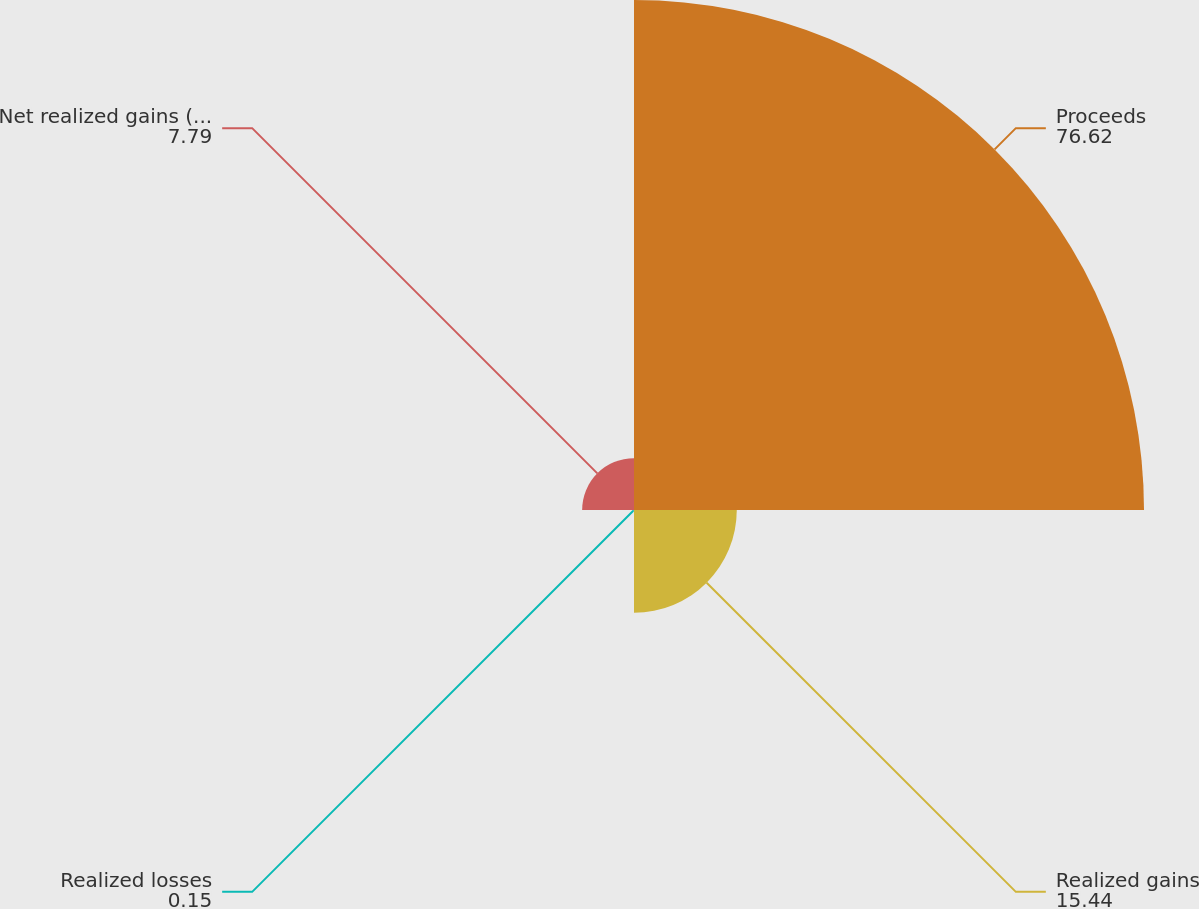<chart> <loc_0><loc_0><loc_500><loc_500><pie_chart><fcel>Proceeds<fcel>Realized gains<fcel>Realized losses<fcel>Net realized gains (losses)<nl><fcel>76.62%<fcel>15.44%<fcel>0.15%<fcel>7.79%<nl></chart> 